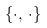Convert formula to latex. <formula><loc_0><loc_0><loc_500><loc_500>\ \{ \cdot , \, \cdot \}</formula> 